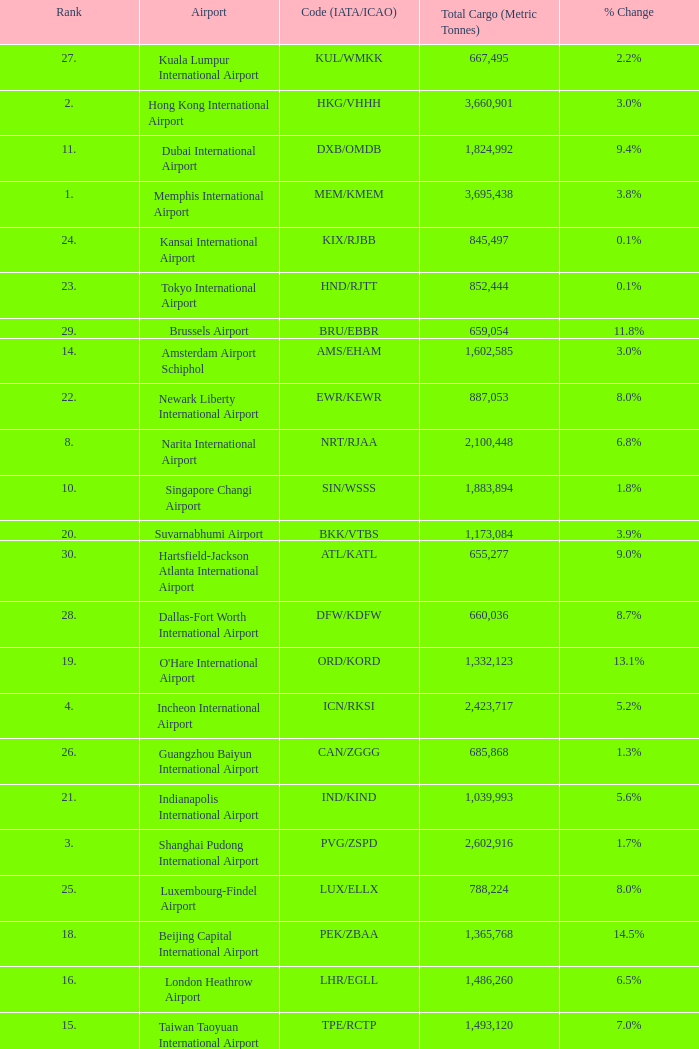What is the rank for ord/kord with more than 1,332,123 total cargo? None. 